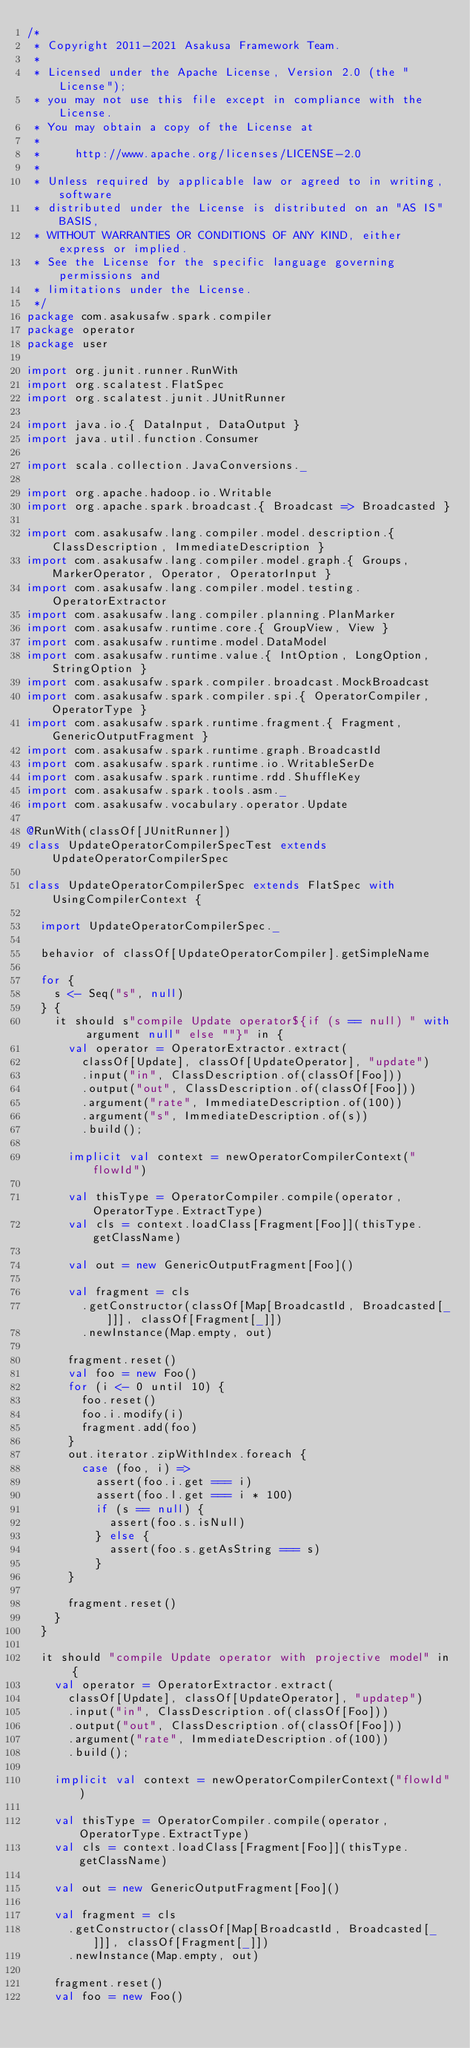Convert code to text. <code><loc_0><loc_0><loc_500><loc_500><_Scala_>/*
 * Copyright 2011-2021 Asakusa Framework Team.
 *
 * Licensed under the Apache License, Version 2.0 (the "License");
 * you may not use this file except in compliance with the License.
 * You may obtain a copy of the License at
 *
 *     http://www.apache.org/licenses/LICENSE-2.0
 *
 * Unless required by applicable law or agreed to in writing, software
 * distributed under the License is distributed on an "AS IS" BASIS,
 * WITHOUT WARRANTIES OR CONDITIONS OF ANY KIND, either express or implied.
 * See the License for the specific language governing permissions and
 * limitations under the License.
 */
package com.asakusafw.spark.compiler
package operator
package user

import org.junit.runner.RunWith
import org.scalatest.FlatSpec
import org.scalatest.junit.JUnitRunner

import java.io.{ DataInput, DataOutput }
import java.util.function.Consumer

import scala.collection.JavaConversions._

import org.apache.hadoop.io.Writable
import org.apache.spark.broadcast.{ Broadcast => Broadcasted }

import com.asakusafw.lang.compiler.model.description.{ ClassDescription, ImmediateDescription }
import com.asakusafw.lang.compiler.model.graph.{ Groups, MarkerOperator, Operator, OperatorInput }
import com.asakusafw.lang.compiler.model.testing.OperatorExtractor
import com.asakusafw.lang.compiler.planning.PlanMarker
import com.asakusafw.runtime.core.{ GroupView, View }
import com.asakusafw.runtime.model.DataModel
import com.asakusafw.runtime.value.{ IntOption, LongOption, StringOption }
import com.asakusafw.spark.compiler.broadcast.MockBroadcast
import com.asakusafw.spark.compiler.spi.{ OperatorCompiler, OperatorType }
import com.asakusafw.spark.runtime.fragment.{ Fragment, GenericOutputFragment }
import com.asakusafw.spark.runtime.graph.BroadcastId
import com.asakusafw.spark.runtime.io.WritableSerDe
import com.asakusafw.spark.runtime.rdd.ShuffleKey
import com.asakusafw.spark.tools.asm._
import com.asakusafw.vocabulary.operator.Update

@RunWith(classOf[JUnitRunner])
class UpdateOperatorCompilerSpecTest extends UpdateOperatorCompilerSpec

class UpdateOperatorCompilerSpec extends FlatSpec with UsingCompilerContext {

  import UpdateOperatorCompilerSpec._

  behavior of classOf[UpdateOperatorCompiler].getSimpleName

  for {
    s <- Seq("s", null)
  } {
    it should s"compile Update operator${if (s == null) " with argument null" else ""}" in {
      val operator = OperatorExtractor.extract(
        classOf[Update], classOf[UpdateOperator], "update")
        .input("in", ClassDescription.of(classOf[Foo]))
        .output("out", ClassDescription.of(classOf[Foo]))
        .argument("rate", ImmediateDescription.of(100))
        .argument("s", ImmediateDescription.of(s))
        .build();

      implicit val context = newOperatorCompilerContext("flowId")

      val thisType = OperatorCompiler.compile(operator, OperatorType.ExtractType)
      val cls = context.loadClass[Fragment[Foo]](thisType.getClassName)

      val out = new GenericOutputFragment[Foo]()

      val fragment = cls
        .getConstructor(classOf[Map[BroadcastId, Broadcasted[_]]], classOf[Fragment[_]])
        .newInstance(Map.empty, out)

      fragment.reset()
      val foo = new Foo()
      for (i <- 0 until 10) {
        foo.reset()
        foo.i.modify(i)
        fragment.add(foo)
      }
      out.iterator.zipWithIndex.foreach {
        case (foo, i) =>
          assert(foo.i.get === i)
          assert(foo.l.get === i * 100)
          if (s == null) {
            assert(foo.s.isNull)
          } else {
            assert(foo.s.getAsString === s)
          }
      }

      fragment.reset()
    }
  }

  it should "compile Update operator with projective model" in {
    val operator = OperatorExtractor.extract(
      classOf[Update], classOf[UpdateOperator], "updatep")
      .input("in", ClassDescription.of(classOf[Foo]))
      .output("out", ClassDescription.of(classOf[Foo]))
      .argument("rate", ImmediateDescription.of(100))
      .build();

    implicit val context = newOperatorCompilerContext("flowId")

    val thisType = OperatorCompiler.compile(operator, OperatorType.ExtractType)
    val cls = context.loadClass[Fragment[Foo]](thisType.getClassName)

    val out = new GenericOutputFragment[Foo]()

    val fragment = cls
      .getConstructor(classOf[Map[BroadcastId, Broadcasted[_]]], classOf[Fragment[_]])
      .newInstance(Map.empty, out)

    fragment.reset()
    val foo = new Foo()</code> 